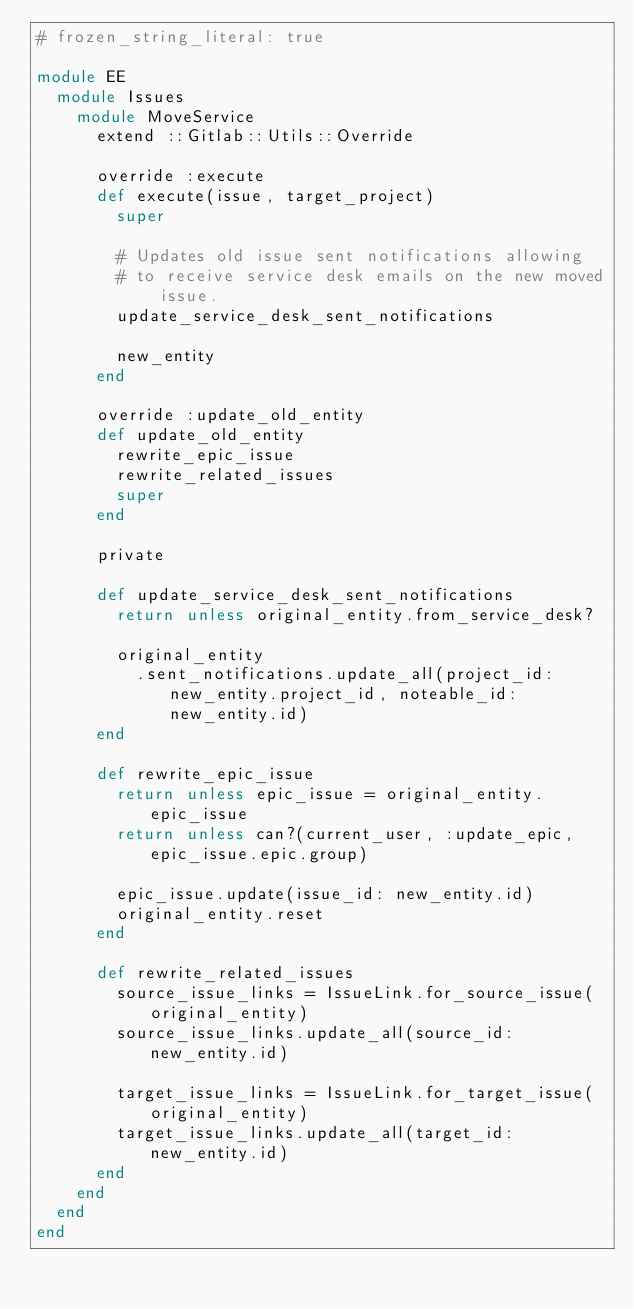<code> <loc_0><loc_0><loc_500><loc_500><_Ruby_># frozen_string_literal: true

module EE
  module Issues
    module MoveService
      extend ::Gitlab::Utils::Override

      override :execute
      def execute(issue, target_project)
        super

        # Updates old issue sent notifications allowing
        # to receive service desk emails on the new moved issue.
        update_service_desk_sent_notifications

        new_entity
      end

      override :update_old_entity
      def update_old_entity
        rewrite_epic_issue
        rewrite_related_issues
        super
      end

      private

      def update_service_desk_sent_notifications
        return unless original_entity.from_service_desk?

        original_entity
          .sent_notifications.update_all(project_id: new_entity.project_id, noteable_id: new_entity.id)
      end

      def rewrite_epic_issue
        return unless epic_issue = original_entity.epic_issue
        return unless can?(current_user, :update_epic, epic_issue.epic.group)

        epic_issue.update(issue_id: new_entity.id)
        original_entity.reset
      end

      def rewrite_related_issues
        source_issue_links = IssueLink.for_source_issue(original_entity)
        source_issue_links.update_all(source_id: new_entity.id)

        target_issue_links = IssueLink.for_target_issue(original_entity)
        target_issue_links.update_all(target_id: new_entity.id)
      end
    end
  end
end
</code> 